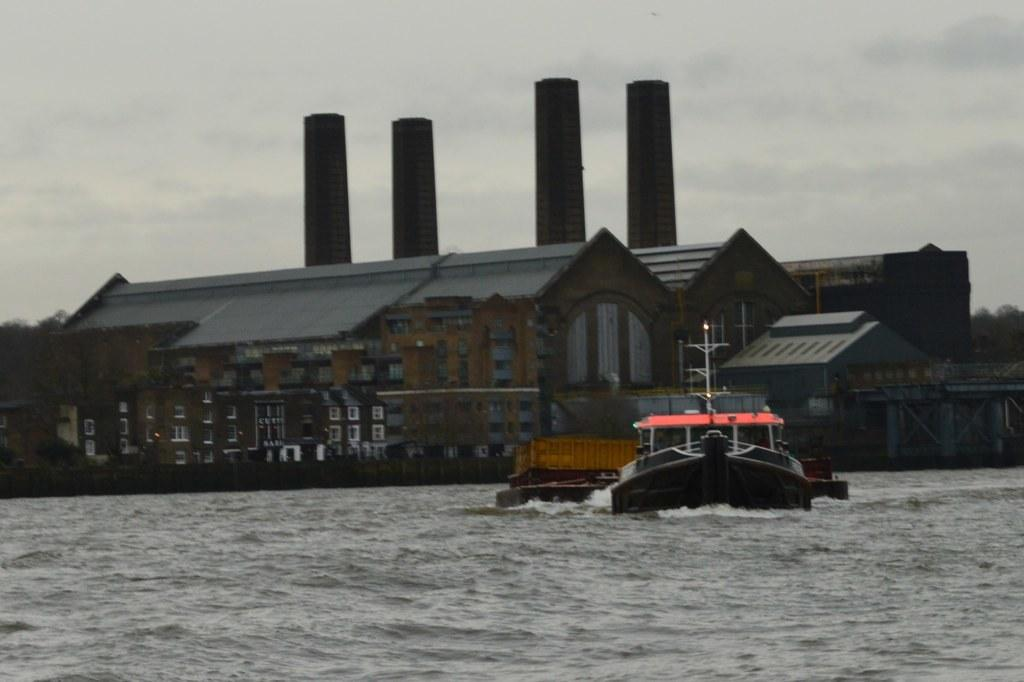What is the main subject of the image? The main subject of the image is a boat. Where is the boat located? The boat is on the water. What can be seen in the background of the image? There are buildings with windows and the sky visible in the background. How many dinosaurs are swimming alongside the boat in the image? There are no dinosaurs present in the image; it features a boat on the water with buildings and the sky in the background. 